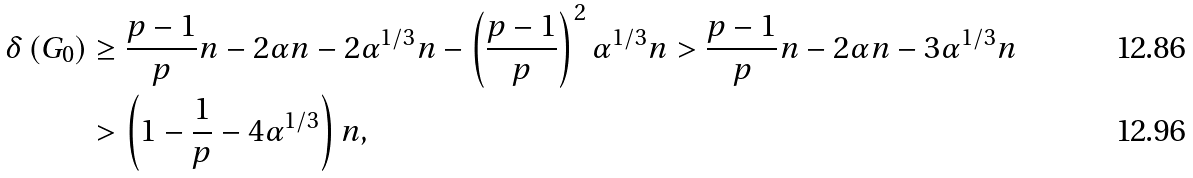<formula> <loc_0><loc_0><loc_500><loc_500>\delta \left ( G _ { 0 } \right ) & \geq \frac { p - 1 } { p } n - 2 \alpha n - 2 \alpha ^ { 1 / 3 } n - \left ( \frac { p - 1 } { p } \right ) ^ { 2 } \alpha ^ { 1 / 3 } n > \frac { p - 1 } { p } n - 2 \alpha n - 3 \alpha ^ { 1 / 3 } n \\ & > \left ( 1 - \frac { 1 } { p } - 4 \alpha ^ { 1 / 3 } \right ) n ,</formula> 